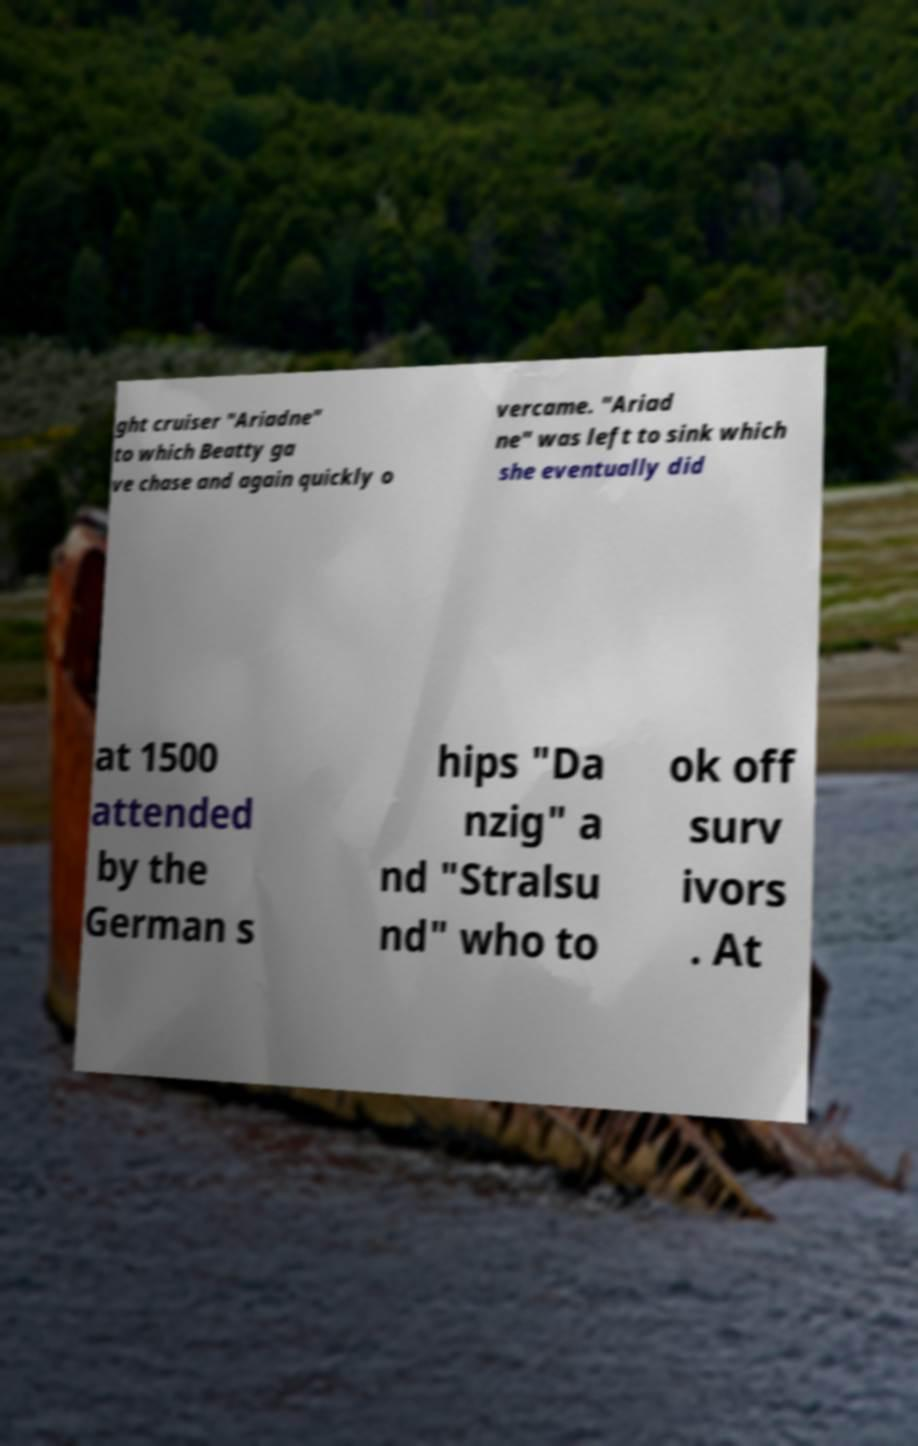What messages or text are displayed in this image? I need them in a readable, typed format. ght cruiser "Ariadne" to which Beatty ga ve chase and again quickly o vercame. "Ariad ne" was left to sink which she eventually did at 1500 attended by the German s hips "Da nzig" a nd "Stralsu nd" who to ok off surv ivors . At 